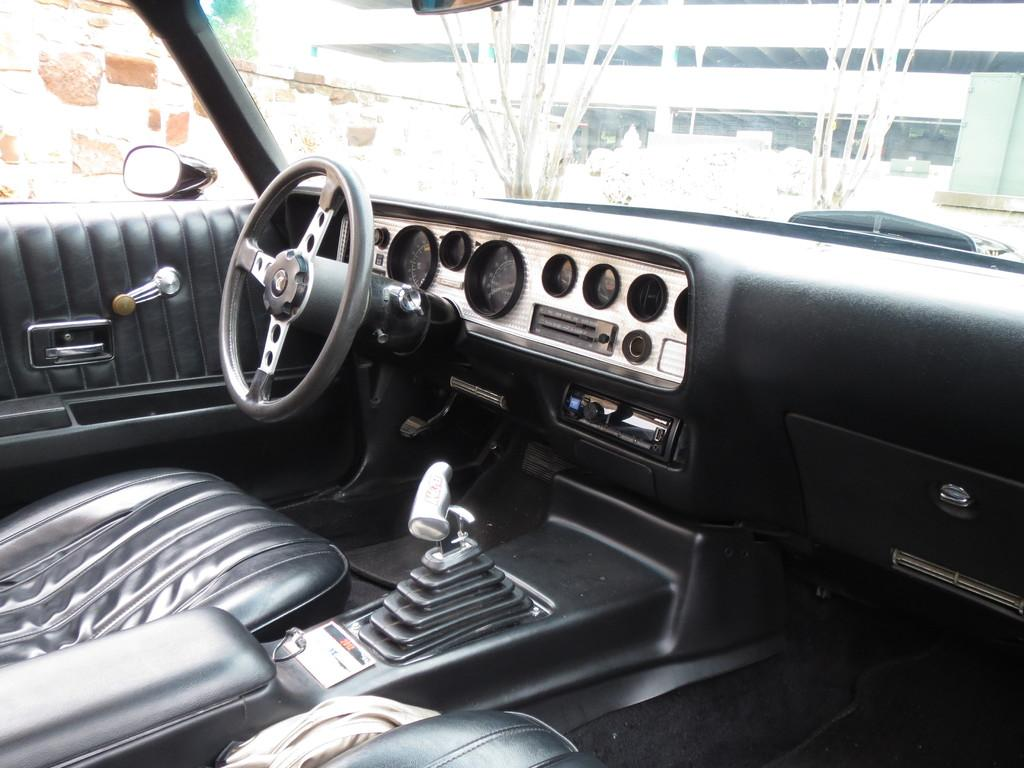What is the setting of the image? The image shows the interior of a car. What can be seen outside the car in the image? There is a building visible in the image, as well as trees. What is the background of the image composed of? The background of the image includes a wall and trees. What objects can be seen on a surface in the image? There are objects on a surface in the image, but their specific nature is not mentioned in the facts. Can you tell me the value of the ocean in the image? There is no ocean present in the image, so it is not possible to determine its value. 